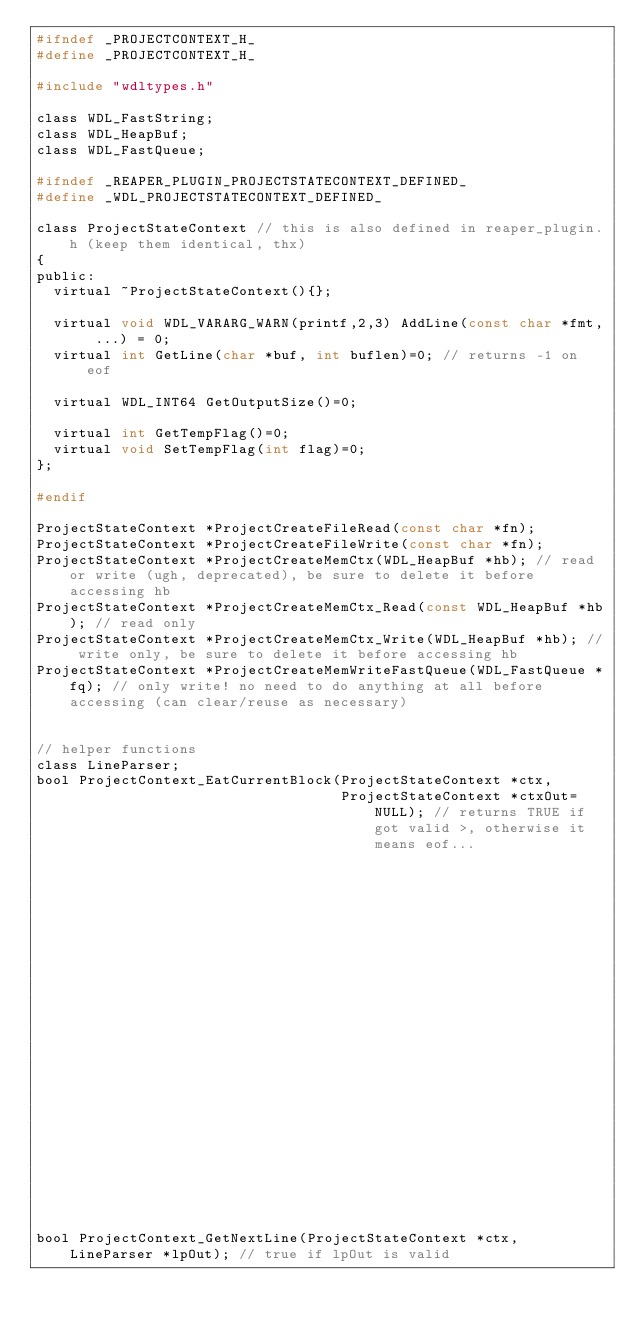<code> <loc_0><loc_0><loc_500><loc_500><_C_>#ifndef _PROJECTCONTEXT_H_
#define _PROJECTCONTEXT_H_

#include "wdltypes.h"

class WDL_FastString;
class WDL_HeapBuf;
class WDL_FastQueue;

#ifndef _REAPER_PLUGIN_PROJECTSTATECONTEXT_DEFINED_
#define _WDL_PROJECTSTATECONTEXT_DEFINED_

class ProjectStateContext // this is also defined in reaper_plugin.h (keep them identical, thx)
{
public:
  virtual ~ProjectStateContext(){};

  virtual void WDL_VARARG_WARN(printf,2,3) AddLine(const char *fmt, ...) = 0;
  virtual int GetLine(char *buf, int buflen)=0; // returns -1 on eof

  virtual WDL_INT64 GetOutputSize()=0;

  virtual int GetTempFlag()=0;
  virtual void SetTempFlag(int flag)=0;
};

#endif

ProjectStateContext *ProjectCreateFileRead(const char *fn);
ProjectStateContext *ProjectCreateFileWrite(const char *fn);
ProjectStateContext *ProjectCreateMemCtx(WDL_HeapBuf *hb); // read or write (ugh, deprecated), be sure to delete it before accessing hb
ProjectStateContext *ProjectCreateMemCtx_Read(const WDL_HeapBuf *hb); // read only 
ProjectStateContext *ProjectCreateMemCtx_Write(WDL_HeapBuf *hb); // write only, be sure to delete it before accessing hb
ProjectStateContext *ProjectCreateMemWriteFastQueue(WDL_FastQueue *fq); // only write! no need to do anything at all before accessing (can clear/reuse as necessary)


// helper functions
class LineParser;
bool ProjectContext_EatCurrentBlock(ProjectStateContext *ctx,
                                    ProjectStateContext *ctxOut=NULL); // returns TRUE if got valid >, otherwise it means eof... 
                                                                       // writes to ctxOut if specified, will not write final >

bool ProjectContext_GetNextLine(ProjectStateContext *ctx, LineParser *lpOut); // true if lpOut is valid
</code> 